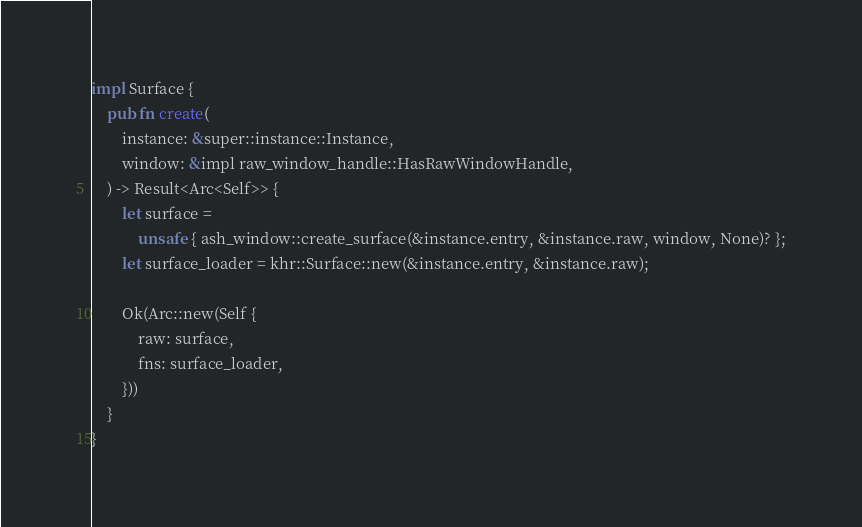Convert code to text. <code><loc_0><loc_0><loc_500><loc_500><_Rust_>
impl Surface {
    pub fn create(
        instance: &super::instance::Instance,
        window: &impl raw_window_handle::HasRawWindowHandle,
    ) -> Result<Arc<Self>> {
        let surface =
            unsafe { ash_window::create_surface(&instance.entry, &instance.raw, window, None)? };
        let surface_loader = khr::Surface::new(&instance.entry, &instance.raw);

        Ok(Arc::new(Self {
            raw: surface,
            fns: surface_loader,
        }))
    }
}
</code> 